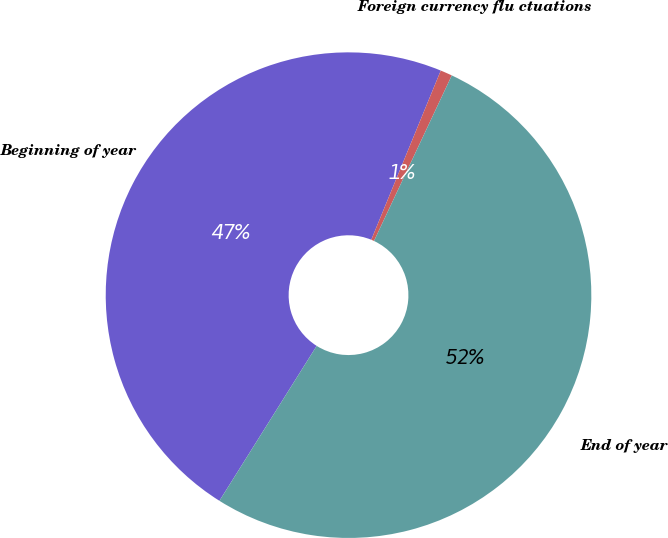Convert chart. <chart><loc_0><loc_0><loc_500><loc_500><pie_chart><fcel>Beginning of year<fcel>Foreign currency flu ctuations<fcel>End of year<nl><fcel>47.28%<fcel>0.79%<fcel>51.93%<nl></chart> 